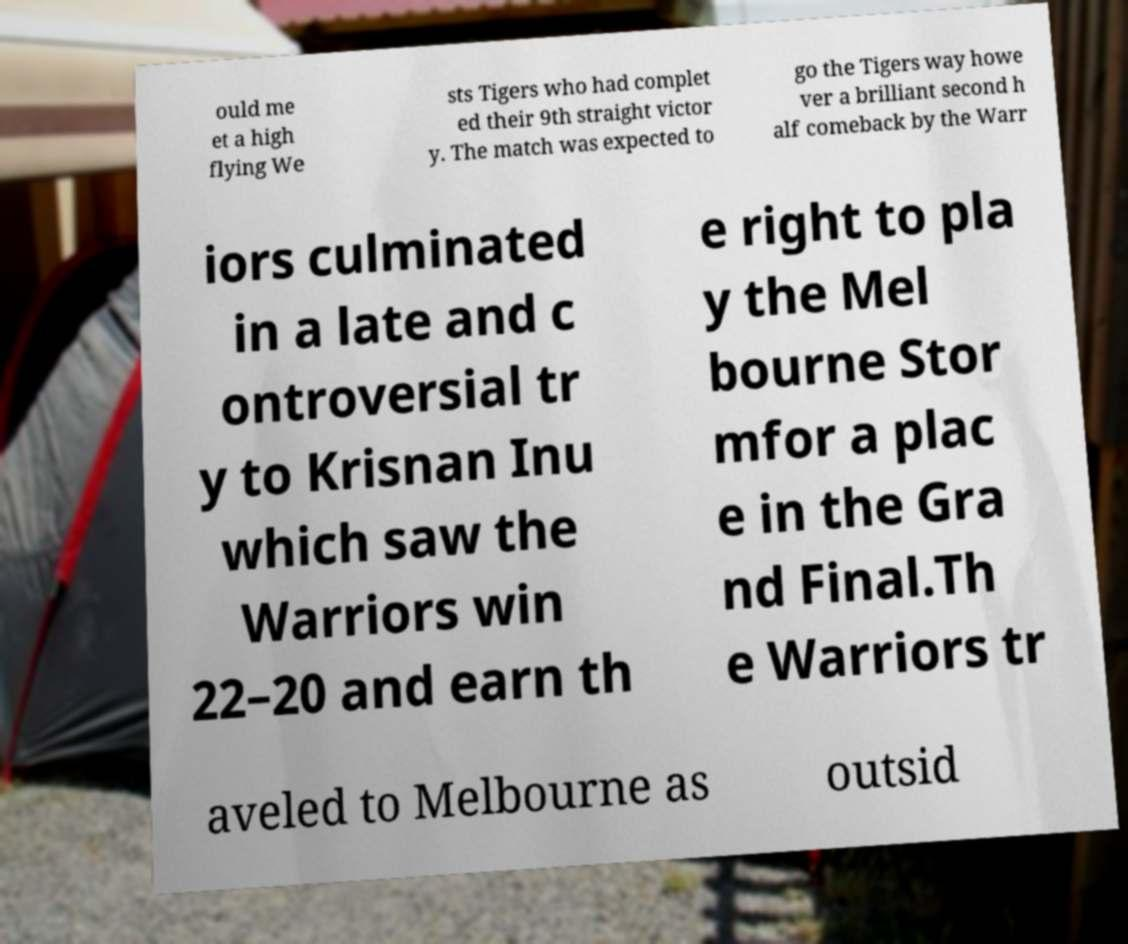Could you assist in decoding the text presented in this image and type it out clearly? ould me et a high flying We sts Tigers who had complet ed their 9th straight victor y. The match was expected to go the Tigers way howe ver a brilliant second h alf comeback by the Warr iors culminated in a late and c ontroversial tr y to Krisnan Inu which saw the Warriors win 22–20 and earn th e right to pla y the Mel bourne Stor mfor a plac e in the Gra nd Final.Th e Warriors tr aveled to Melbourne as outsid 